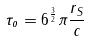<formula> <loc_0><loc_0><loc_500><loc_500>\tau _ { o } = 6 ^ { \frac { 3 } { 2 } } \pi \frac { r _ { S } } { c }</formula> 